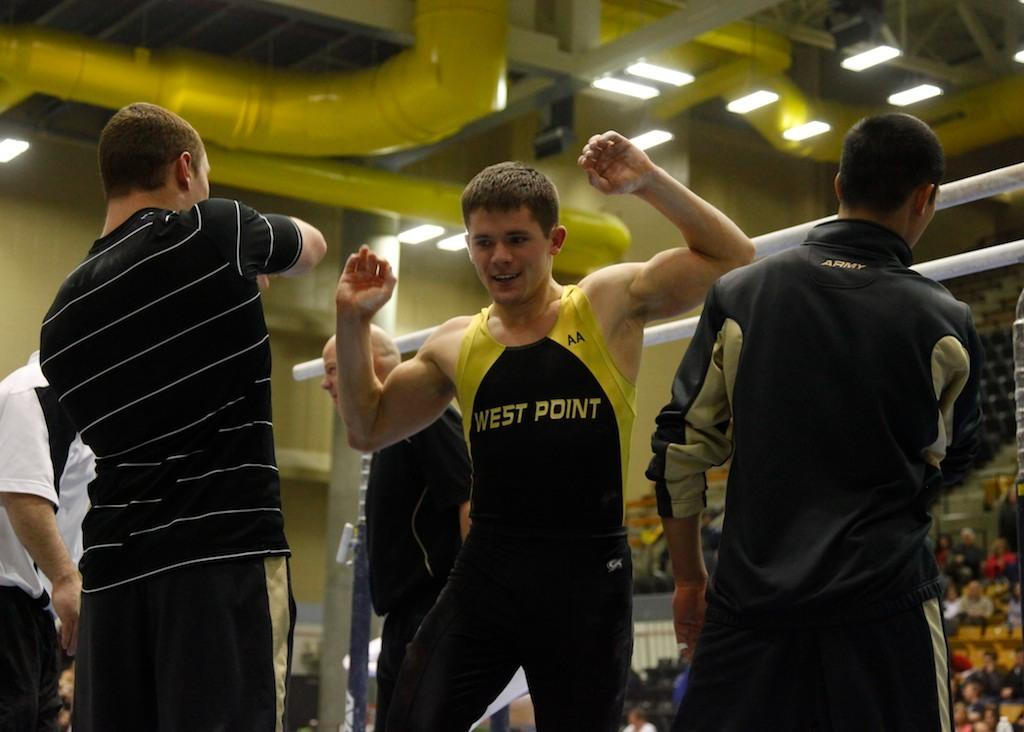<image>
Provide a brief description of the given image. An athlete from West Point with his arms raised. 